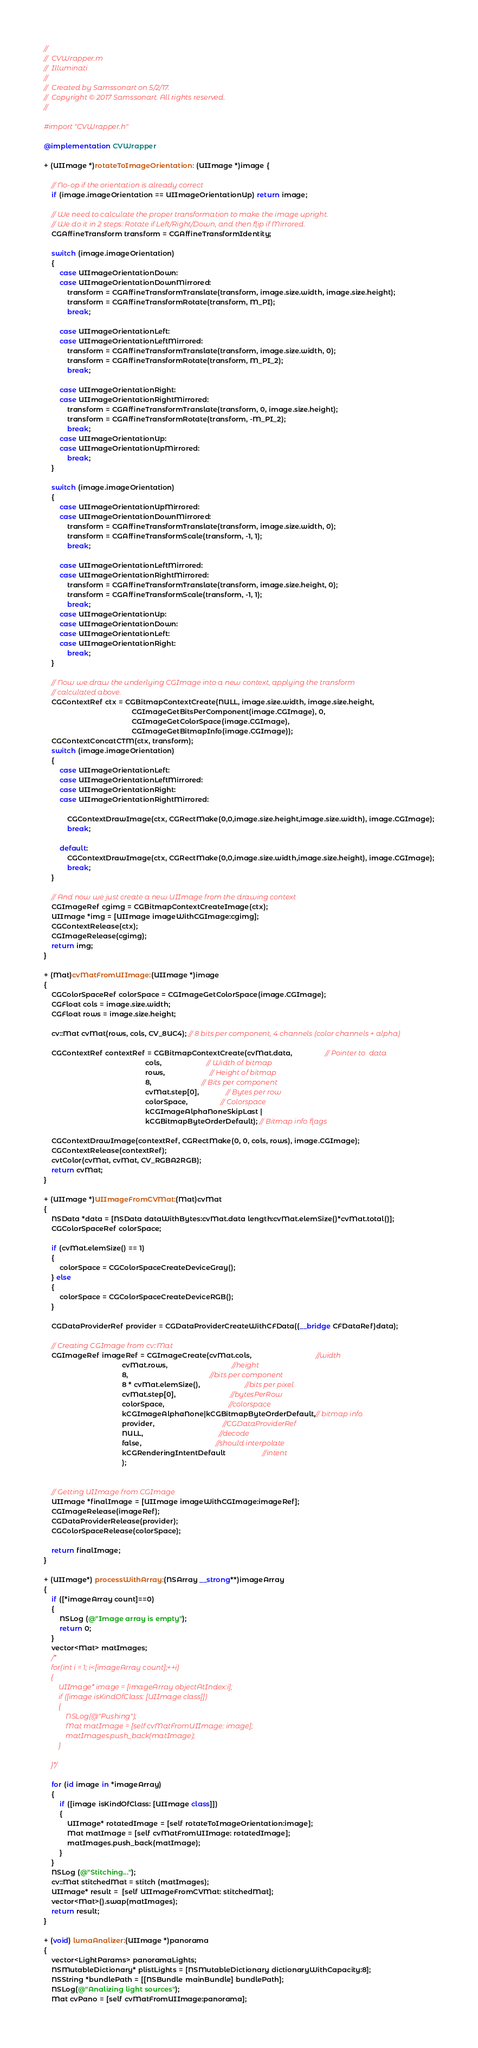Convert code to text. <code><loc_0><loc_0><loc_500><loc_500><_ObjectiveC_>//
//  CVWrapper.m
//  Illuminati
//
//  Created by Samssonart on 5/2/17.
//  Copyright © 2017 Samssonart. All rights reserved.
//

#import "CVWrapper.h"

@implementation CVWrapper

+ (UIImage *)rotateToImageOrientation: (UIImage *)image {
    
    // No-op if the orientation is already correct
    if (image.imageOrientation == UIImageOrientationUp) return image;
    
    // We need to calculate the proper transformation to make the image upright.
    // We do it in 2 steps: Rotate if Left/Right/Down, and then flip if Mirrored.
    CGAffineTransform transform = CGAffineTransformIdentity;
    
    switch (image.imageOrientation)
    {
        case UIImageOrientationDown:
        case UIImageOrientationDownMirrored:
            transform = CGAffineTransformTranslate(transform, image.size.width, image.size.height);
            transform = CGAffineTransformRotate(transform, M_PI);
            break;
            
        case UIImageOrientationLeft:
        case UIImageOrientationLeftMirrored:
            transform = CGAffineTransformTranslate(transform, image.size.width, 0);
            transform = CGAffineTransformRotate(transform, M_PI_2);
            break;
            
        case UIImageOrientationRight:
        case UIImageOrientationRightMirrored:
            transform = CGAffineTransformTranslate(transform, 0, image.size.height);
            transform = CGAffineTransformRotate(transform, -M_PI_2);
            break;
        case UIImageOrientationUp:
        case UIImageOrientationUpMirrored:
            break;
    }
    
    switch (image.imageOrientation)
    {
        case UIImageOrientationUpMirrored:
        case UIImageOrientationDownMirrored:
            transform = CGAffineTransformTranslate(transform, image.size.width, 0);
            transform = CGAffineTransformScale(transform, -1, 1);
            break;
            
        case UIImageOrientationLeftMirrored:
        case UIImageOrientationRightMirrored:
            transform = CGAffineTransformTranslate(transform, image.size.height, 0);
            transform = CGAffineTransformScale(transform, -1, 1);
            break;
        case UIImageOrientationUp:
        case UIImageOrientationDown:
        case UIImageOrientationLeft:
        case UIImageOrientationRight:
            break;
    }
    
    // Now we draw the underlying CGImage into a new context, applying the transform
    // calculated above.
    CGContextRef ctx = CGBitmapContextCreate(NULL, image.size.width, image.size.height,
                                             CGImageGetBitsPerComponent(image.CGImage), 0,
                                             CGImageGetColorSpace(image.CGImage),
                                             CGImageGetBitmapInfo(image.CGImage));
    CGContextConcatCTM(ctx, transform);
    switch (image.imageOrientation)
    {
        case UIImageOrientationLeft:
        case UIImageOrientationLeftMirrored:
        case UIImageOrientationRight:
        case UIImageOrientationRightMirrored:
           
            CGContextDrawImage(ctx, CGRectMake(0,0,image.size.height,image.size.width), image.CGImage);
            break;
            
        default:
            CGContextDrawImage(ctx, CGRectMake(0,0,image.size.width,image.size.height), image.CGImage);
            break;
    }
    
    // And now we just create a new UIImage from the drawing context
    CGImageRef cgimg = CGBitmapContextCreateImage(ctx);
    UIImage *img = [UIImage imageWithCGImage:cgimg];
    CGContextRelease(ctx);
    CGImageRelease(cgimg);
    return img;
}

+ (Mat)cvMatFromUIImage:(UIImage *)image
{
    CGColorSpaceRef colorSpace = CGImageGetColorSpace(image.CGImage);
    CGFloat cols = image.size.width;
    CGFloat rows = image.size.height;
    
    cv::Mat cvMat(rows, cols, CV_8UC4); // 8 bits per component, 4 channels (color channels + alpha)
    
    CGContextRef contextRef = CGBitmapContextCreate(cvMat.data,                 // Pointer to  data
                                                    cols,                       // Width of bitmap
                                                    rows,                       // Height of bitmap
                                                    8,                          // Bits per component
                                                    cvMat.step[0],              // Bytes per row
                                                    colorSpace,                 // Colorspace
                                                    kCGImageAlphaNoneSkipLast |
                                                    kCGBitmapByteOrderDefault); // Bitmap info flags
    
    CGContextDrawImage(contextRef, CGRectMake(0, 0, cols, rows), image.CGImage);
    CGContextRelease(contextRef);
    cvtColor(cvMat, cvMat, CV_RGBA2RGB);
    return cvMat;
}

+ (UIImage *)UIImageFromCVMat:(Mat)cvMat
{
    NSData *data = [NSData dataWithBytes:cvMat.data length:cvMat.elemSize()*cvMat.total()];
    CGColorSpaceRef colorSpace;
    
    if (cvMat.elemSize() == 1)
    {
        colorSpace = CGColorSpaceCreateDeviceGray();
    } else
    {
        colorSpace = CGColorSpaceCreateDeviceRGB();
    }
    
    CGDataProviderRef provider = CGDataProviderCreateWithCFData((__bridge CFDataRef)data);
    
    // Creating CGImage from cv::Mat
    CGImageRef imageRef = CGImageCreate(cvMat.cols,                                 //width
                                        cvMat.rows,                                 //height
                                        8,                                          //bits per component
                                        8 * cvMat.elemSize(),                       //bits per pixel
                                        cvMat.step[0],                            //bytesPerRow
                                        colorSpace,                                 //colorspace
                                        kCGImageAlphaNone|kCGBitmapByteOrderDefault,// bitmap info
                                        provider,                                   //CGDataProviderRef
                                        NULL,                                       //decode
                                        false,                                      //should interpolate
                                        kCGRenderingIntentDefault                   //intent
                                        );
    
    
    // Getting UIImage from CGImage
    UIImage *finalImage = [UIImage imageWithCGImage:imageRef];
    CGImageRelease(imageRef);
    CGDataProviderRelease(provider);
    CGColorSpaceRelease(colorSpace);
    
    return finalImage;
}

+ (UIImage*) processWithArray:(NSArray __strong**)imageArray
{
    if ([*imageArray count]==0)
    {
        NSLog (@"Image array is empty");
        return 0;
    }
    vector<Mat> matImages;
    /*
    for(int i = 1; i<[imageArray count];++i)
    {
        UIImage* image = [imageArray objectAtIndex:i];
        if ([image isKindOfClass: [UIImage class]])
        {
            NSLog(@"Pushing");
            Mat matImage = [self cvMatFromUIImage: image];
            matImages.push_back(matImage);
        }
        
    }*/
    
    for (id image in *imageArray)
    {
        if ([image isKindOfClass: [UIImage class]])
        {
            UIImage* rotatedImage = [self rotateToImageOrientation:image];
            Mat matImage = [self cvMatFromUIImage: rotatedImage];
            matImages.push_back(matImage);
        }
    }
    NSLog (@"Stitching...");
    cv::Mat stitchedMat = stitch (matImages);
    UIImage* result =  [self UIImageFromCVMat: stitchedMat];
    vector<Mat>().swap(matImages);
    return result;
}

+ (void) lumaAnalizer:(UIImage *)panorama
{
    vector<LightParams> panoramaLights;
    NSMutableDictionary* plistLights = [NSMutableDictionary dictionaryWithCapacity:8];
    NSString *bundlePath = [[NSBundle mainBundle] bundlePath];
    NSLog(@"Analizing light sources");
    Mat cvPano = [self cvMatFromUIImage:panorama];</code> 